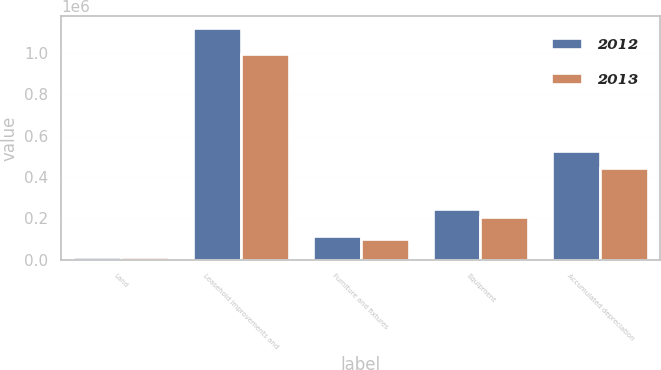<chart> <loc_0><loc_0><loc_500><loc_500><stacked_bar_chart><ecel><fcel>Land<fcel>Leasehold improvements and<fcel>Furniture and fixtures<fcel>Equipment<fcel>Accumulated depreciation<nl><fcel>2012<fcel>11062<fcel>1.12126e+06<fcel>113751<fcel>244562<fcel>527397<nl><fcel>2013<fcel>11062<fcel>996080<fcel>100416<fcel>204062<fcel>444917<nl></chart> 